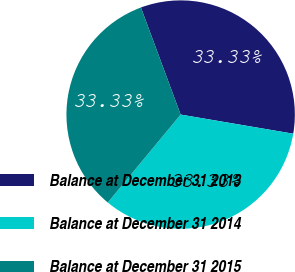Convert chart. <chart><loc_0><loc_0><loc_500><loc_500><pie_chart><fcel>Balance at December 31 2013<fcel>Balance at December 31 2014<fcel>Balance at December 31 2015<nl><fcel>33.33%<fcel>33.33%<fcel>33.33%<nl></chart> 